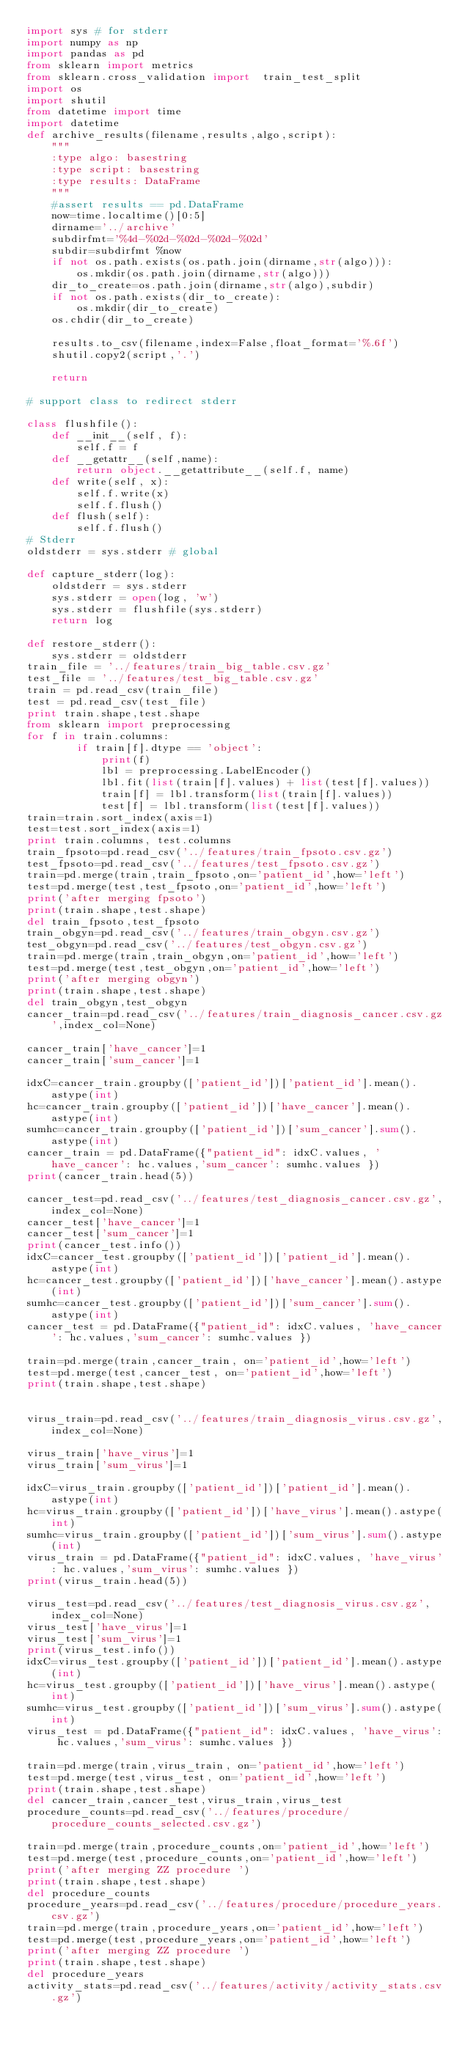Convert code to text. <code><loc_0><loc_0><loc_500><loc_500><_Python_>import sys # for stderr
import numpy as np
import pandas as pd
from sklearn import metrics
from sklearn.cross_validation import  train_test_split
import os
import shutil
from datetime import time
import datetime
def archive_results(filename,results,algo,script):
    """
    :type algo: basestring
    :type script: basestring
    :type results: DataFrame
    """
    #assert results == pd.DataFrame
    now=time.localtime()[0:5]
    dirname='../archive'
    subdirfmt='%4d-%02d-%02d-%02d-%02d'
    subdir=subdirfmt %now
    if not os.path.exists(os.path.join(dirname,str(algo))):
        os.mkdir(os.path.join(dirname,str(algo)))
    dir_to_create=os.path.join(dirname,str(algo),subdir)
    if not os.path.exists(dir_to_create):
        os.mkdir(dir_to_create)
    os.chdir(dir_to_create)

    results.to_csv(filename,index=False,float_format='%.6f')
    shutil.copy2(script,'.')

    return

# support class to redirect stderr

class flushfile():
    def __init__(self, f):
        self.f = f
    def __getattr__(self,name):
        return object.__getattribute__(self.f, name)
    def write(self, x):
        self.f.write(x)
        self.f.flush()
    def flush(self):
        self.f.flush()
# Stderr
oldstderr = sys.stderr # global

def capture_stderr(log):
    oldstderr = sys.stderr
    sys.stderr = open(log, 'w')
    sys.stderr = flushfile(sys.stderr)
    return log

def restore_stderr():
    sys.stderr = oldstderr
train_file = '../features/train_big_table.csv.gz'
test_file = '../features/test_big_table.csv.gz'
train = pd.read_csv(train_file)
test = pd.read_csv(test_file)
print train.shape,test.shape
from sklearn import preprocessing
for f in train.columns:
        if train[f].dtype == 'object':
            print(f)
            lbl = preprocessing.LabelEncoder()
            lbl.fit(list(train[f].values) + list(test[f].values))
            train[f] = lbl.transform(list(train[f].values))
            test[f] = lbl.transform(list(test[f].values))
train=train.sort_index(axis=1)
test=test.sort_index(axis=1)
print train.columns, test.columns
train_fpsoto=pd.read_csv('../features/train_fpsoto.csv.gz')
test_fpsoto=pd.read_csv('../features/test_fpsoto.csv.gz')
train=pd.merge(train,train_fpsoto,on='patient_id',how='left')
test=pd.merge(test,test_fpsoto,on='patient_id',how='left')
print('after merging fpsoto')
print(train.shape,test.shape)
del train_fpsoto,test_fpsoto
train_obgyn=pd.read_csv('../features/train_obgyn.csv.gz')
test_obgyn=pd.read_csv('../features/test_obgyn.csv.gz')
train=pd.merge(train,train_obgyn,on='patient_id',how='left')
test=pd.merge(test,test_obgyn,on='patient_id',how='left')
print('after merging obgyn')
print(train.shape,test.shape)
del train_obgyn,test_obgyn
cancer_train=pd.read_csv('../features/train_diagnosis_cancer.csv.gz',index_col=None)

cancer_train['have_cancer']=1
cancer_train['sum_cancer']=1

idxC=cancer_train.groupby(['patient_id'])['patient_id'].mean().astype(int)
hc=cancer_train.groupby(['patient_id'])['have_cancer'].mean().astype(int)
sumhc=cancer_train.groupby(['patient_id'])['sum_cancer'].sum().astype(int)
cancer_train = pd.DataFrame({"patient_id": idxC.values, 'have_cancer': hc.values,'sum_cancer': sumhc.values })
print(cancer_train.head(5))

cancer_test=pd.read_csv('../features/test_diagnosis_cancer.csv.gz',index_col=None)
cancer_test['have_cancer']=1
cancer_test['sum_cancer']=1
print(cancer_test.info())
idxC=cancer_test.groupby(['patient_id'])['patient_id'].mean().astype(int)
hc=cancer_test.groupby(['patient_id'])['have_cancer'].mean().astype(int)
sumhc=cancer_test.groupby(['patient_id'])['sum_cancer'].sum().astype(int)
cancer_test = pd.DataFrame({"patient_id": idxC.values, 'have_cancer': hc.values,'sum_cancer': sumhc.values })

train=pd.merge(train,cancer_train, on='patient_id',how='left')
test=pd.merge(test,cancer_test, on='patient_id',how='left')
print(train.shape,test.shape)


virus_train=pd.read_csv('../features/train_diagnosis_virus.csv.gz',index_col=None)

virus_train['have_virus']=1
virus_train['sum_virus']=1

idxC=virus_train.groupby(['patient_id'])['patient_id'].mean().astype(int)
hc=virus_train.groupby(['patient_id'])['have_virus'].mean().astype(int)
sumhc=virus_train.groupby(['patient_id'])['sum_virus'].sum().astype(int)
virus_train = pd.DataFrame({"patient_id": idxC.values, 'have_virus': hc.values,'sum_virus': sumhc.values })
print(virus_train.head(5))

virus_test=pd.read_csv('../features/test_diagnosis_virus.csv.gz',index_col=None)
virus_test['have_virus']=1
virus_test['sum_virus']=1
print(virus_test.info())
idxC=virus_test.groupby(['patient_id'])['patient_id'].mean().astype(int)
hc=virus_test.groupby(['patient_id'])['have_virus'].mean().astype(int)
sumhc=virus_test.groupby(['patient_id'])['sum_virus'].sum().astype(int)
virus_test = pd.DataFrame({"patient_id": idxC.values, 'have_virus': hc.values,'sum_virus': sumhc.values })

train=pd.merge(train,virus_train, on='patient_id',how='left')
test=pd.merge(test,virus_test, on='patient_id',how='left')
print(train.shape,test.shape)
del cancer_train,cancer_test,virus_train,virus_test
procedure_counts=pd.read_csv('../features/procedure/procedure_counts_selected.csv.gz')

train=pd.merge(train,procedure_counts,on='patient_id',how='left')
test=pd.merge(test,procedure_counts,on='patient_id',how='left')
print('after merging ZZ procedure ')
print(train.shape,test.shape)
del procedure_counts
procedure_years=pd.read_csv('../features/procedure/procedure_years.csv.gz')
train=pd.merge(train,procedure_years,on='patient_id',how='left')
test=pd.merge(test,procedure_years,on='patient_id',how='left')
print('after merging ZZ procedure ')
print(train.shape,test.shape)
del procedure_years
activity_stats=pd.read_csv('../features/activity/activity_stats.csv.gz')</code> 